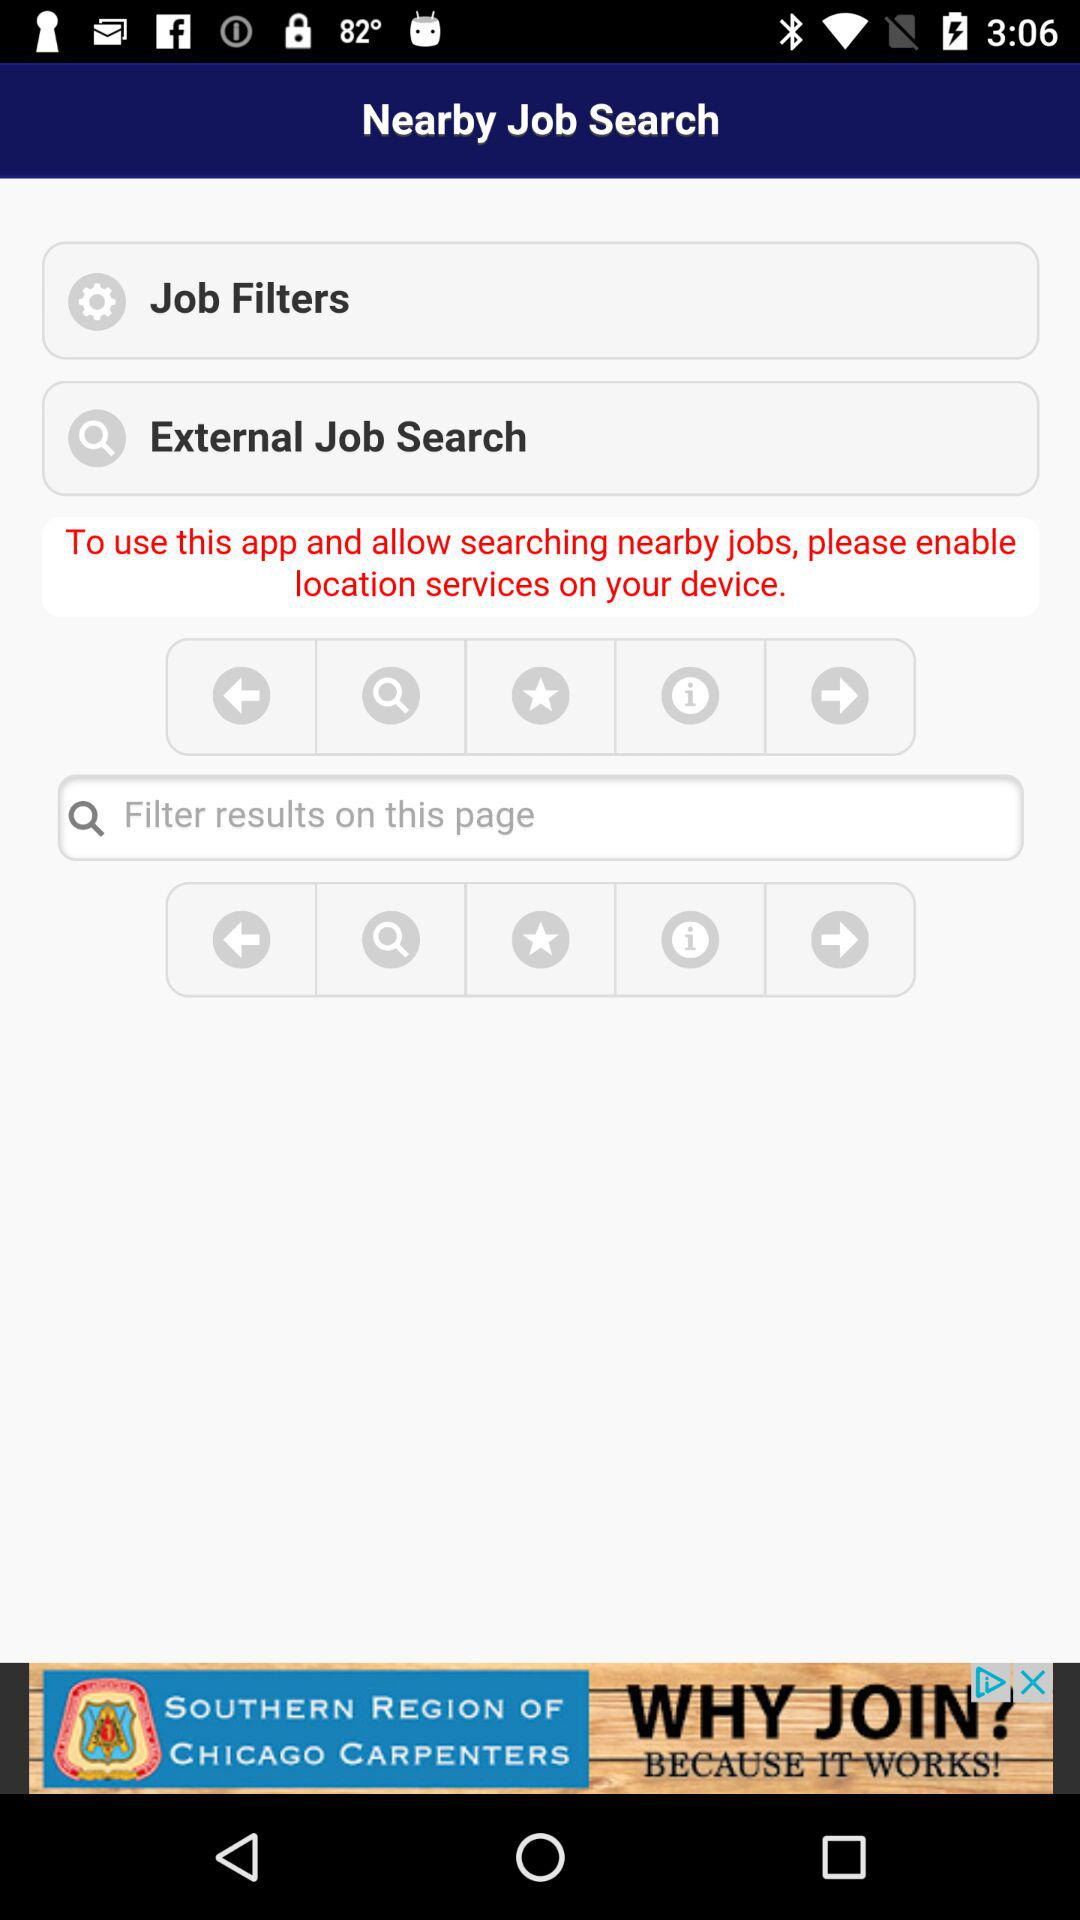What do we need to enable in order to search for nearby jobs? In order to search for nearby jobs, you need to enable location services on your device. 